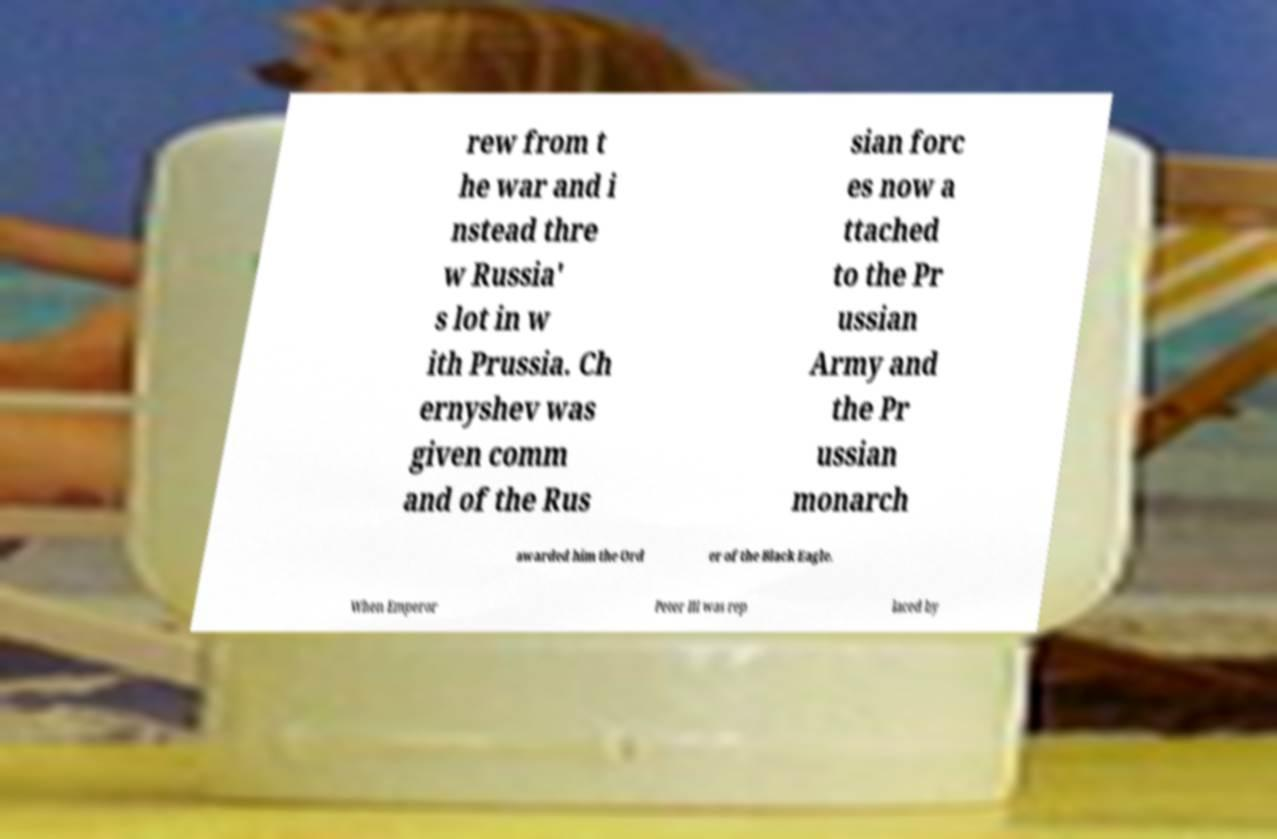What messages or text are displayed in this image? I need them in a readable, typed format. rew from t he war and i nstead thre w Russia' s lot in w ith Prussia. Ch ernyshev was given comm and of the Rus sian forc es now a ttached to the Pr ussian Army and the Pr ussian monarch awarded him the Ord er of the Black Eagle. When Emperor Peter III was rep laced by 